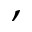Convert formula to latex. <formula><loc_0><loc_0><loc_500><loc_500>,</formula> 